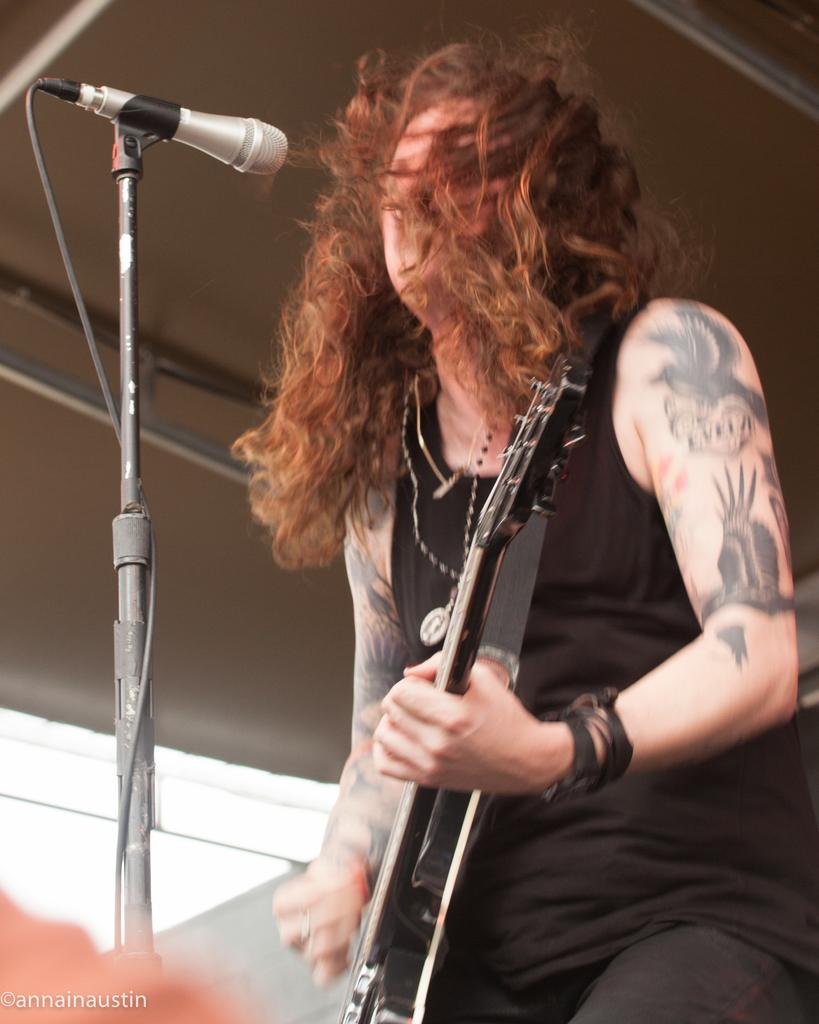What is the woman in the image doing? The woman is playing a guitar in the image. What is the woman positioned in front of? The woman is in front of a microphone. What is the microphone attached to? The microphone has a holder. What is the woman wearing? The woman is wearing a black t-shirt. What can be observed on the woman's hands? The woman has tattoos on her hands. How many kittens are sitting on the woman's shoulders in the image? There are no kittens present in the image; the woman is playing a guitar and standing in front of a microphone. 